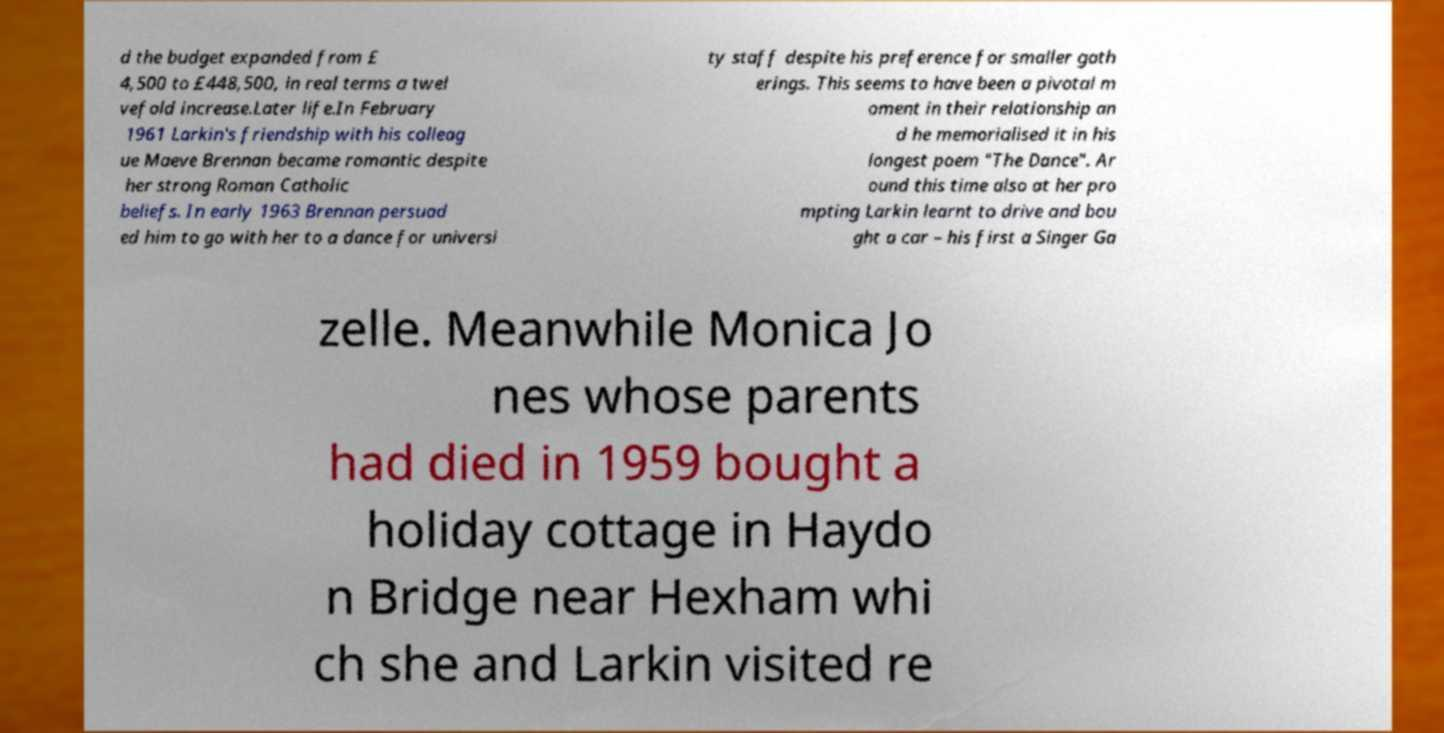I need the written content from this picture converted into text. Can you do that? d the budget expanded from £ 4,500 to £448,500, in real terms a twel vefold increase.Later life.In February 1961 Larkin's friendship with his colleag ue Maeve Brennan became romantic despite her strong Roman Catholic beliefs. In early 1963 Brennan persuad ed him to go with her to a dance for universi ty staff despite his preference for smaller gath erings. This seems to have been a pivotal m oment in their relationship an d he memorialised it in his longest poem "The Dance". Ar ound this time also at her pro mpting Larkin learnt to drive and bou ght a car – his first a Singer Ga zelle. Meanwhile Monica Jo nes whose parents had died in 1959 bought a holiday cottage in Haydo n Bridge near Hexham whi ch she and Larkin visited re 